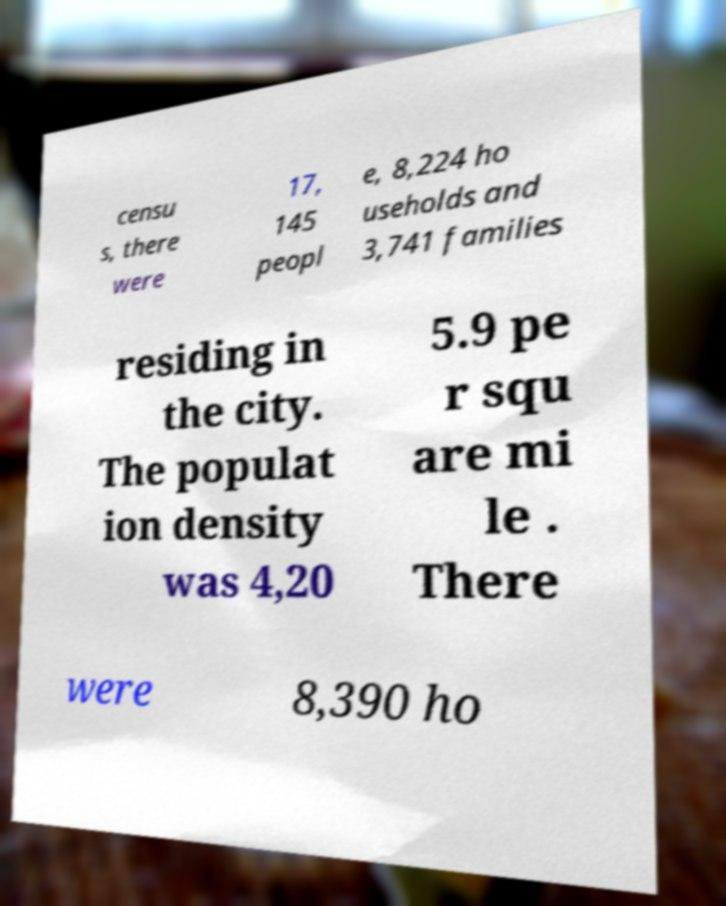Please read and relay the text visible in this image. What does it say? censu s, there were 17, 145 peopl e, 8,224 ho useholds and 3,741 families residing in the city. The populat ion density was 4,20 5.9 pe r squ are mi le . There were 8,390 ho 